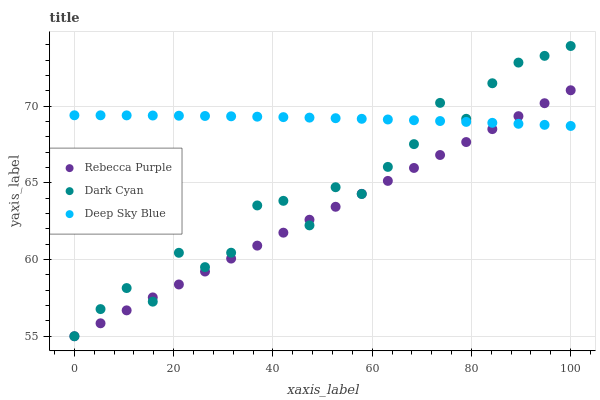Does Rebecca Purple have the minimum area under the curve?
Answer yes or no. Yes. Does Deep Sky Blue have the maximum area under the curve?
Answer yes or no. Yes. Does Deep Sky Blue have the minimum area under the curve?
Answer yes or no. No. Does Rebecca Purple have the maximum area under the curve?
Answer yes or no. No. Is Rebecca Purple the smoothest?
Answer yes or no. Yes. Is Dark Cyan the roughest?
Answer yes or no. Yes. Is Deep Sky Blue the smoothest?
Answer yes or no. No. Is Deep Sky Blue the roughest?
Answer yes or no. No. Does Dark Cyan have the lowest value?
Answer yes or no. Yes. Does Deep Sky Blue have the lowest value?
Answer yes or no. No. Does Dark Cyan have the highest value?
Answer yes or no. Yes. Does Rebecca Purple have the highest value?
Answer yes or no. No. Does Dark Cyan intersect Deep Sky Blue?
Answer yes or no. Yes. Is Dark Cyan less than Deep Sky Blue?
Answer yes or no. No. Is Dark Cyan greater than Deep Sky Blue?
Answer yes or no. No. 